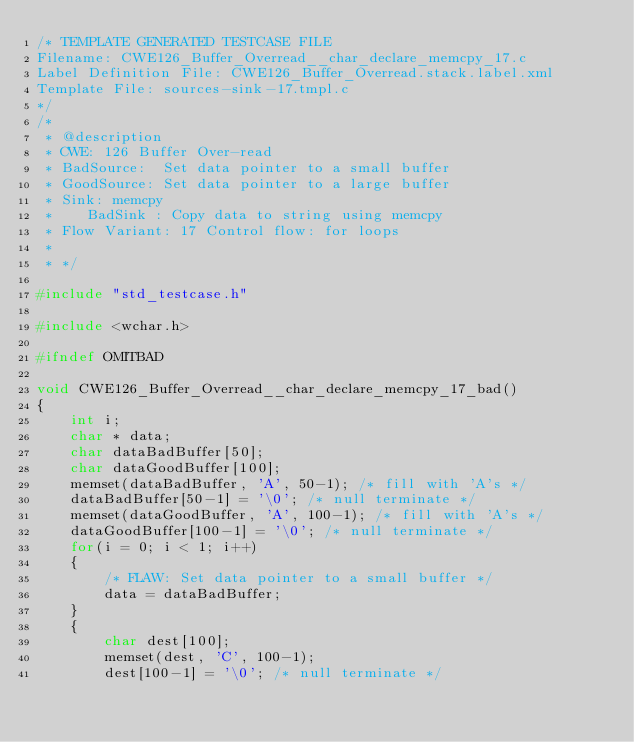<code> <loc_0><loc_0><loc_500><loc_500><_C_>/* TEMPLATE GENERATED TESTCASE FILE
Filename: CWE126_Buffer_Overread__char_declare_memcpy_17.c
Label Definition File: CWE126_Buffer_Overread.stack.label.xml
Template File: sources-sink-17.tmpl.c
*/
/*
 * @description
 * CWE: 126 Buffer Over-read
 * BadSource:  Set data pointer to a small buffer
 * GoodSource: Set data pointer to a large buffer
 * Sink: memcpy
 *    BadSink : Copy data to string using memcpy
 * Flow Variant: 17 Control flow: for loops
 *
 * */

#include "std_testcase.h"

#include <wchar.h>

#ifndef OMITBAD

void CWE126_Buffer_Overread__char_declare_memcpy_17_bad()
{
    int i;
    char * data;
    char dataBadBuffer[50];
    char dataGoodBuffer[100];
    memset(dataBadBuffer, 'A', 50-1); /* fill with 'A's */
    dataBadBuffer[50-1] = '\0'; /* null terminate */
    memset(dataGoodBuffer, 'A', 100-1); /* fill with 'A's */
    dataGoodBuffer[100-1] = '\0'; /* null terminate */
    for(i = 0; i < 1; i++)
    {
        /* FLAW: Set data pointer to a small buffer */
        data = dataBadBuffer;
    }
    {
        char dest[100];
        memset(dest, 'C', 100-1);
        dest[100-1] = '\0'; /* null terminate */</code> 